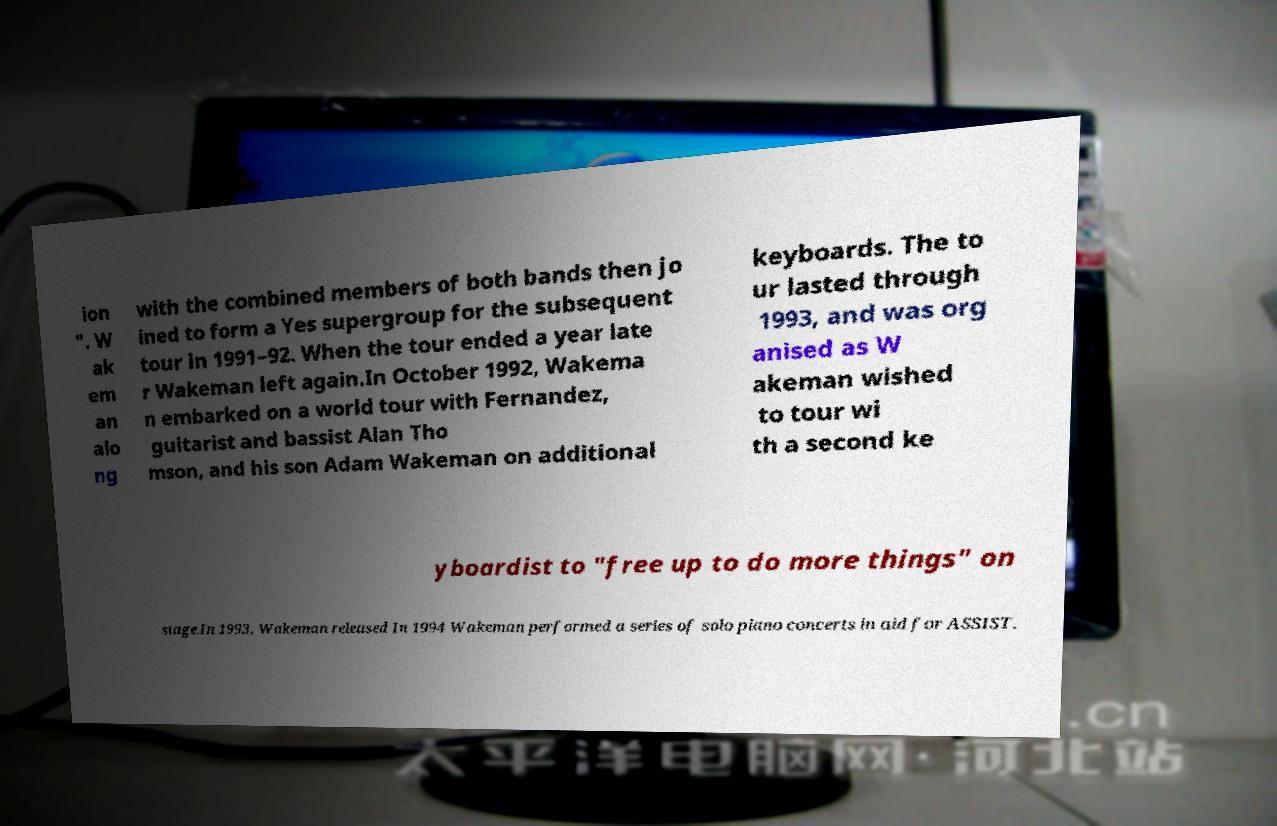For documentation purposes, I need the text within this image transcribed. Could you provide that? ion ". W ak em an alo ng with the combined members of both bands then jo ined to form a Yes supergroup for the subsequent tour in 1991–92. When the tour ended a year late r Wakeman left again.In October 1992, Wakema n embarked on a world tour with Fernandez, guitarist and bassist Alan Tho mson, and his son Adam Wakeman on additional keyboards. The to ur lasted through 1993, and was org anised as W akeman wished to tour wi th a second ke yboardist to "free up to do more things" on stage.In 1993, Wakeman released In 1994 Wakeman performed a series of solo piano concerts in aid for ASSIST. 